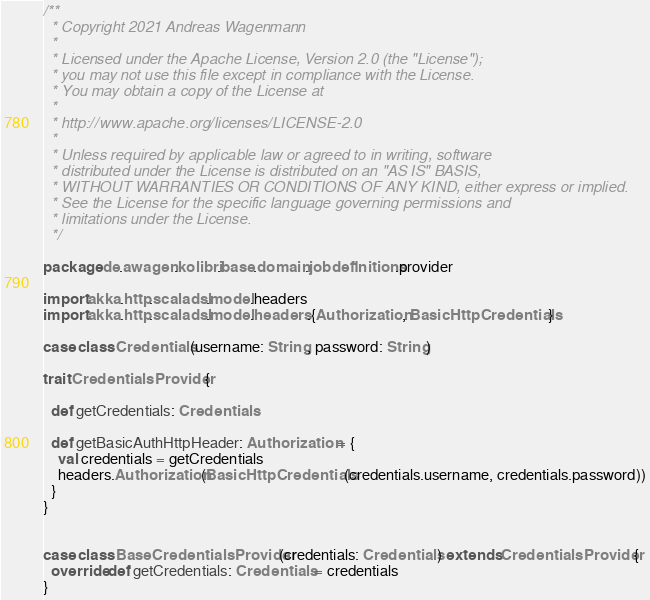Convert code to text. <code><loc_0><loc_0><loc_500><loc_500><_Scala_>/**
  * Copyright 2021 Andreas Wagenmann
  *
  * Licensed under the Apache License, Version 2.0 (the "License");
  * you may not use this file except in compliance with the License.
  * You may obtain a copy of the License at
  *
  * http://www.apache.org/licenses/LICENSE-2.0
  *
  * Unless required by applicable law or agreed to in writing, software
  * distributed under the License is distributed on an "AS IS" BASIS,
  * WITHOUT WARRANTIES OR CONDITIONS OF ANY KIND, either express or implied.
  * See the License for the specific language governing permissions and
  * limitations under the License.
  */

package de.awagen.kolibri.base.domain.jobdefinitions.provider

import akka.http.scaladsl.model.headers
import akka.http.scaladsl.model.headers.{Authorization, BasicHttpCredentials}

case class Credentials(username: String, password: String)

trait CredentialsProvider {

  def getCredentials: Credentials

  def getBasicAuthHttpHeader: Authorization = {
    val credentials = getCredentials
    headers.Authorization(BasicHttpCredentials(credentials.username, credentials.password))
  }
}


case class BaseCredentialsProvider(credentials: Credentials) extends CredentialsProvider {
  override def getCredentials: Credentials = credentials
}</code> 